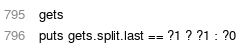Convert code to text. <code><loc_0><loc_0><loc_500><loc_500><_Ruby_>gets
puts gets.split.last == ?1 ? ?1 : ?0</code> 